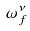Convert formula to latex. <formula><loc_0><loc_0><loc_500><loc_500>\omega _ { f } ^ { \nu }</formula> 